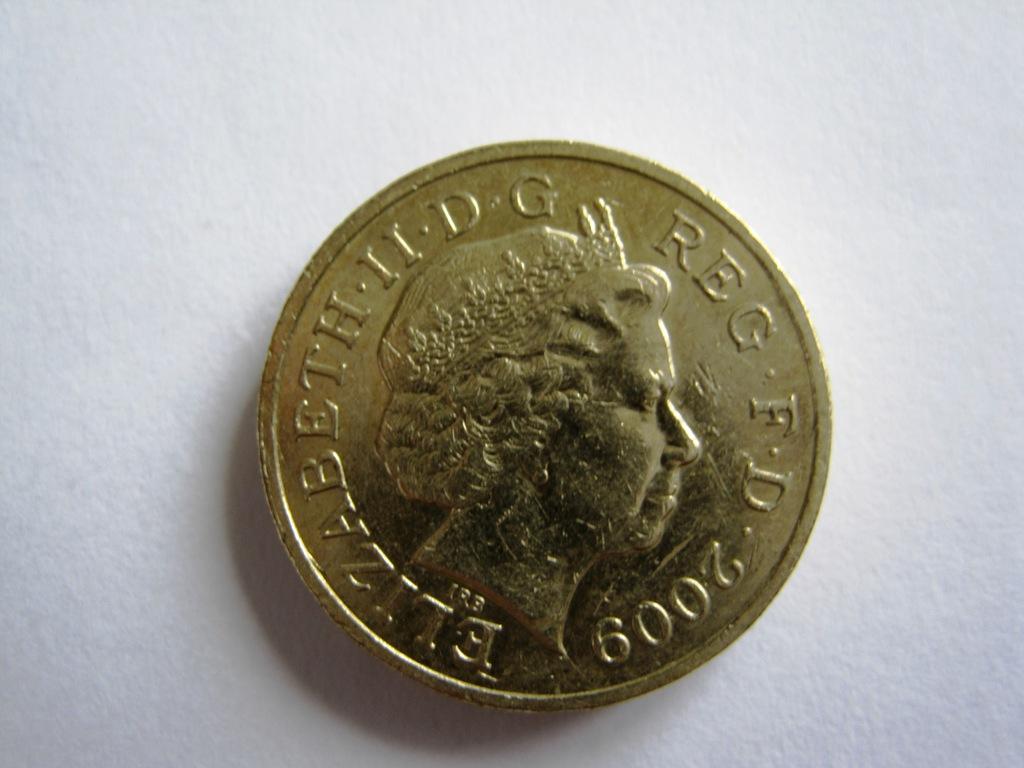In which year is this coin minted?
Your response must be concise. 2009. Whose name is on the coin?
Offer a terse response. Elizabeth. 